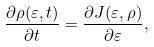<formula> <loc_0><loc_0><loc_500><loc_500>\frac { \partial \rho ( \varepsilon , t ) } { \partial t } = \frac { \partial J ( \varepsilon , \rho ) } { \partial \varepsilon } ,</formula> 